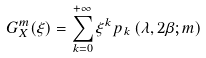Convert formula to latex. <formula><loc_0><loc_0><loc_500><loc_500>G _ { X } ^ { m } ( \xi ) = \sum _ { k = 0 } ^ { + \infty } \xi ^ { k } p _ { k } \left ( \lambda , 2 \beta ; m \right )</formula> 